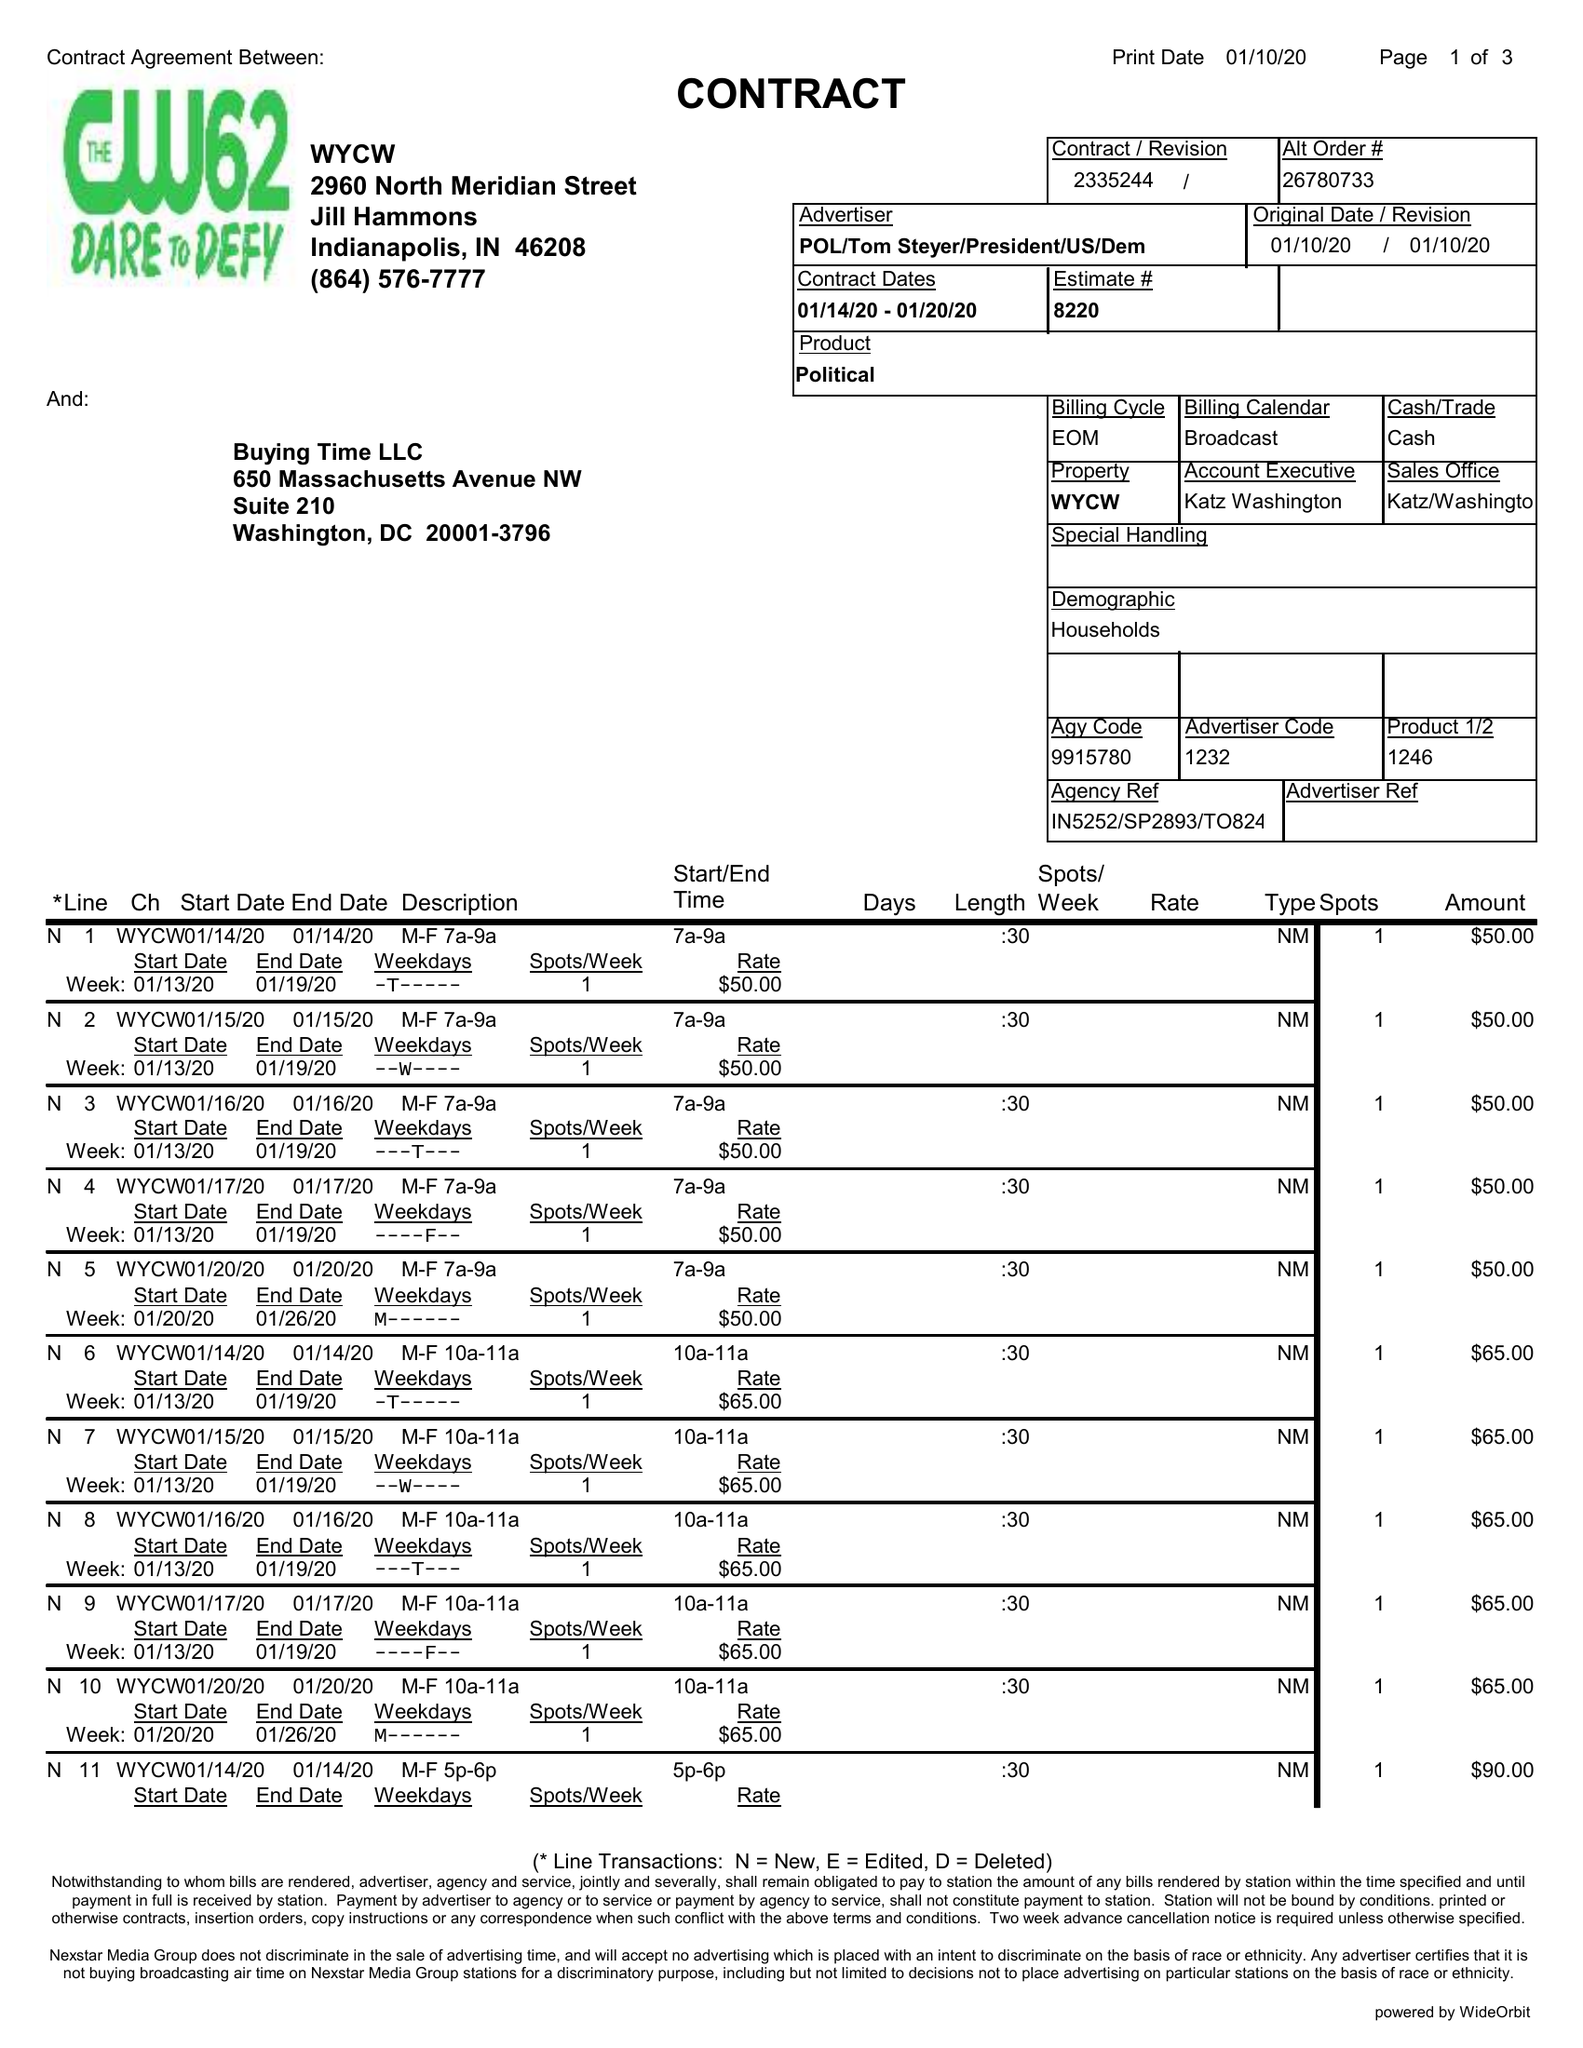What is the value for the flight_from?
Answer the question using a single word or phrase. 01/14/20 